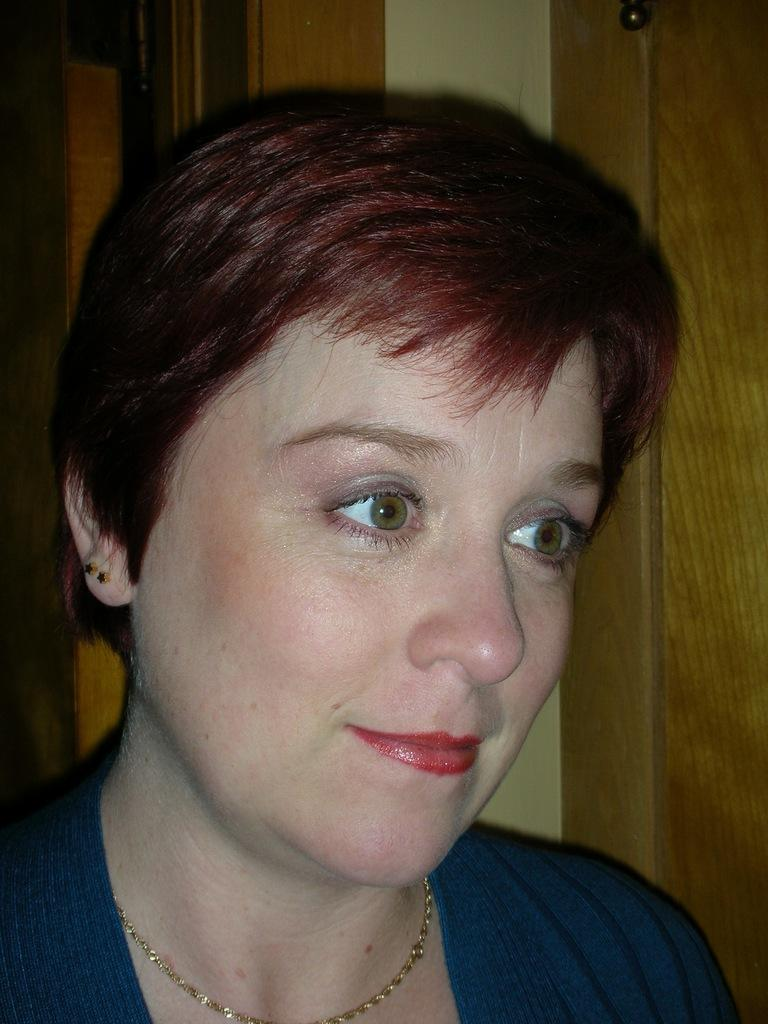What is the main subject of the image? The main subject of the image is a woman. Can you describe any other objects or features visible in the image? Yes, there are other objects visible in the background of the image. What type of card is the woman holding in the image? There is no card present in the image; it only features a woman and other objects in the background. What is the base of the head in the image? There is no head or base mentioned in the image; it only features a woman and other objects in the background. 